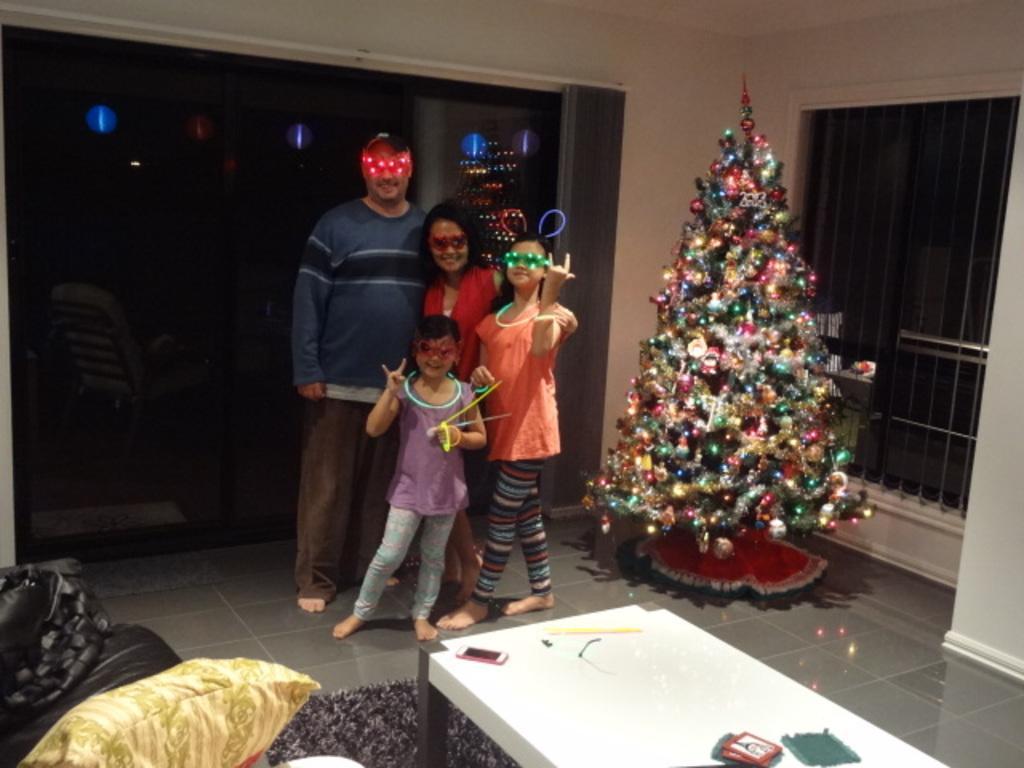Describe this image in one or two sentences. This is the man, woman and two girls standing and smiling. This looks like a Christmas tree, which is decorated. I can see a table with a mobile phone, cards and few other things on it. This is a carpet on the floor. I can see a couch with a cushion. This looks like a glass door. I think this is a window. I can see the reflections of the lights on the glass door. 